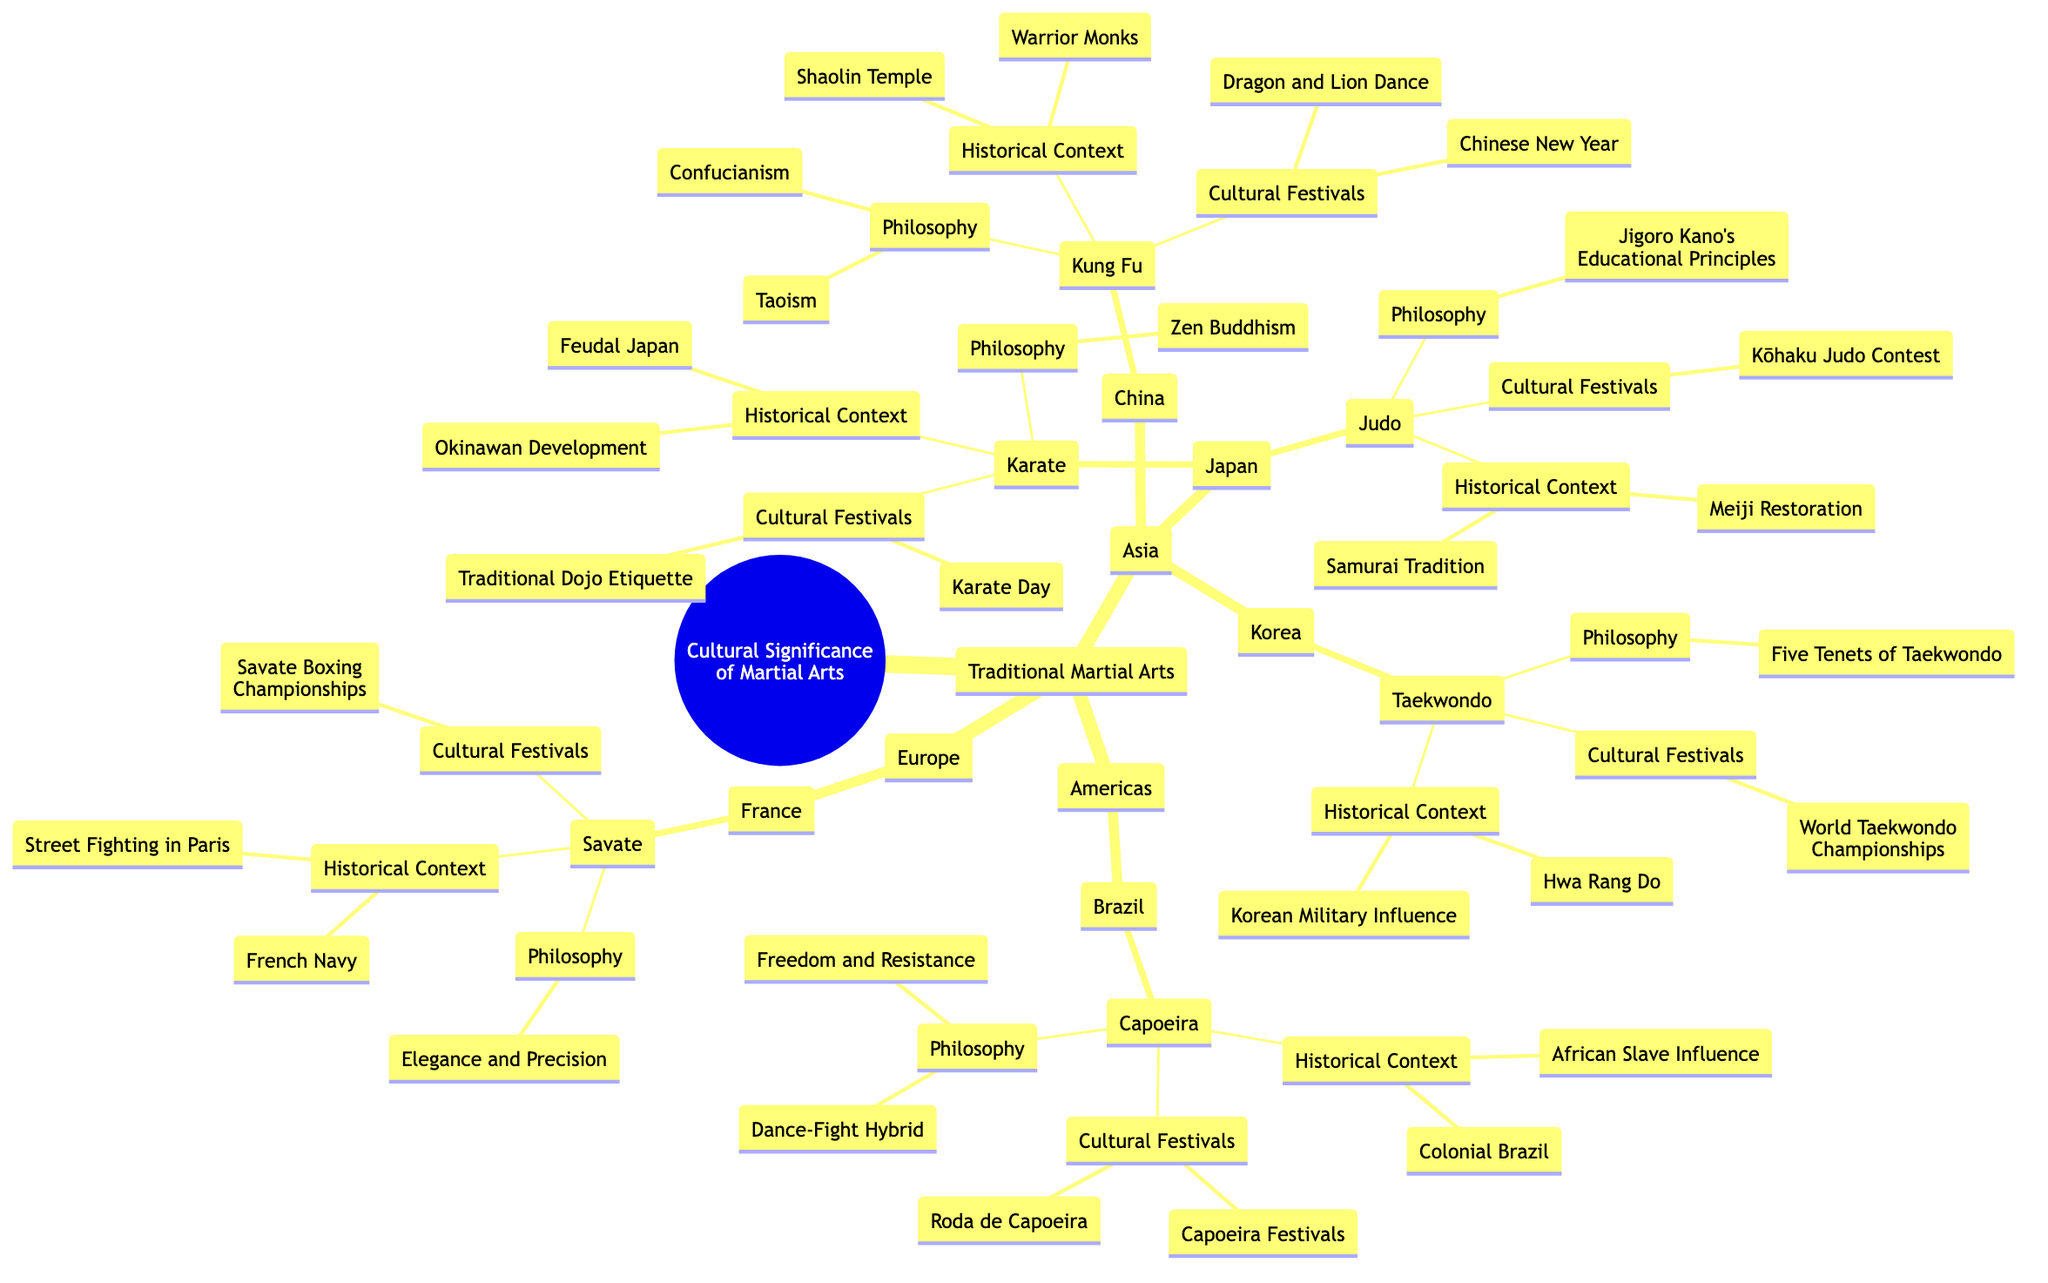What are the three main martial arts listed under Asia? The diagram shows three main martial arts in Asia: Kung Fu, Karate, and Taekwondo. Each corresponds to a specific country.
Answer: Kung Fu, Karate, Taekwondo Which philosophy is associated with Judo? The diagram specifies that Judo is associated with "Jigoro Kano's Educational Principles" under its philosophy node.
Answer: Jigoro Kano's Educational Principles What cultural festival is celebrated for Capoeira? The diagram indicates that two cultural festivals celebrated for Capoeira are "Capoeira Festivals" and "Roda de Capoeira."
Answer: Capoeira Festivals, Roda de Capoeira How many traditional martial arts are listed under Europe? Under Europe, the diagram depicts one traditional martial art: Savate. Hence, the number is straightforward.
Answer: 1 Which historical context is linked to Taekwondo? The diagram mentions that Taekwondo is linked to "Korean Military Influence" and "Hwa Rang Do." From both nodes, the contexts can be identified as historical influences.
Answer: Korean Military Influence, Hwa Rang Do What is the common theme in the philosophies of Kung Fu and Karate? Both Kung Fu and Karate emphasize philosophical teachings related to spirituality; Kung Fu is associated with "Taoism, Confucianism" and Karate with "Zen Buddhism," demonstrating a shared focus on mind-body alignment and spirituality.
Answer: Spirituality What is the relationship between Savate and the French Navy? The diagram indicates that Savate has historical roots connected to "French Navy," which shows a relationship where the martial art developed from practices related to the navy.
Answer: Martial art development from naval practices Which continent has the most traditional martial arts listed in the diagram? Analyzing the diagram, Asia has three martial arts (Kung Fu, Karate, Taekwondo) while the Americas and Europe each have one. Thus, Asia has the most.
Answer: Asia 